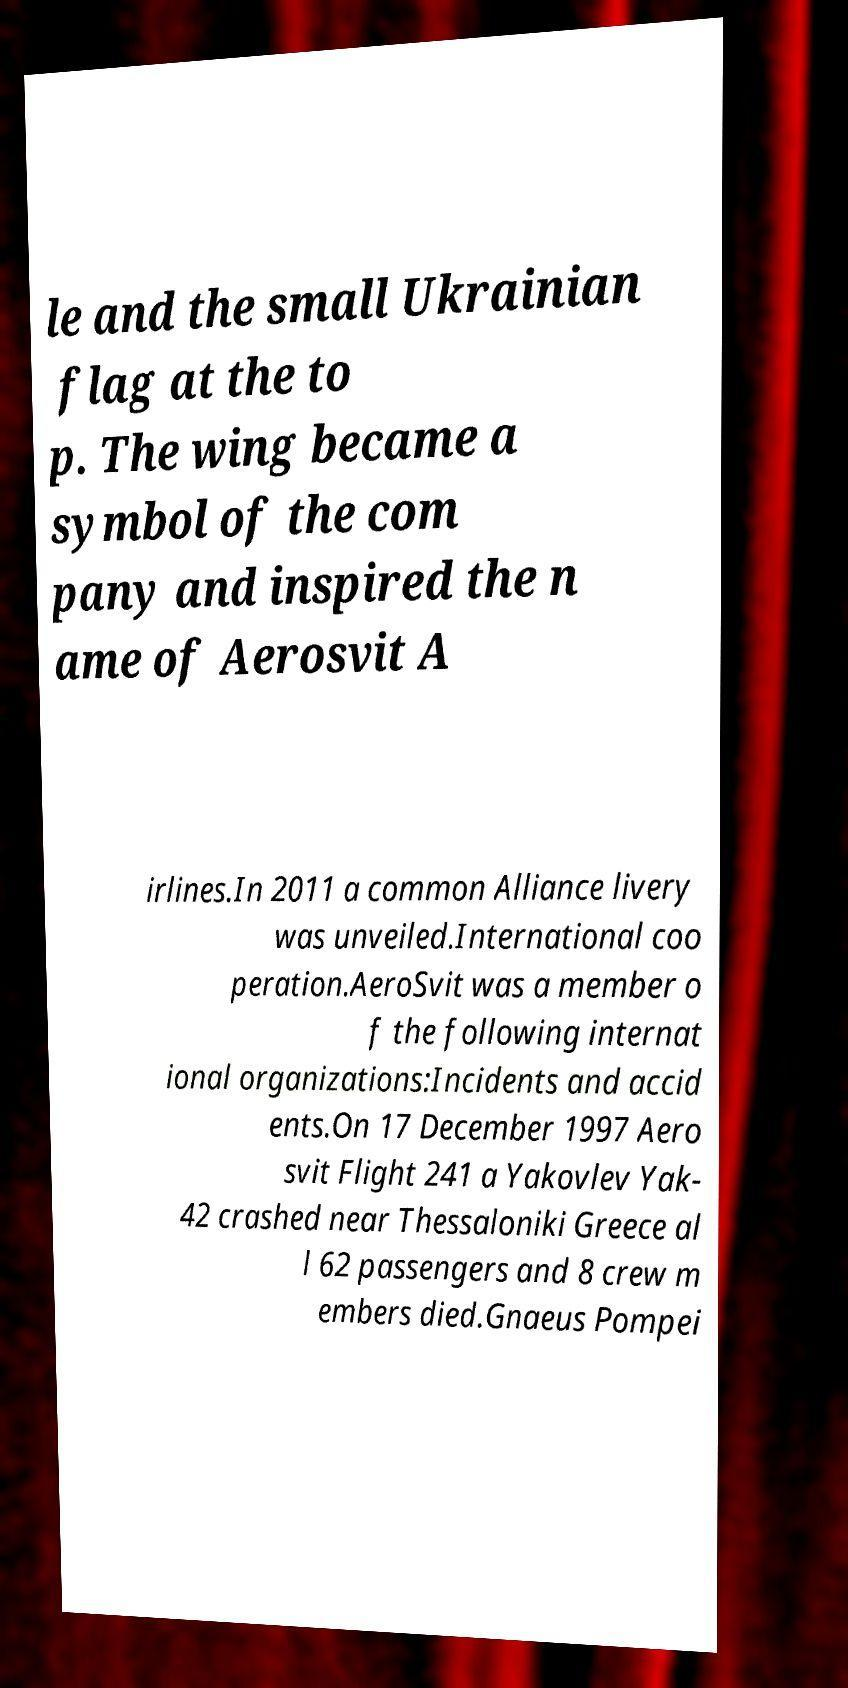Could you extract and type out the text from this image? le and the small Ukrainian flag at the to p. The wing became a symbol of the com pany and inspired the n ame of Aerosvit A irlines.In 2011 a common Alliance livery was unveiled.International coo peration.AeroSvit was a member o f the following internat ional organizations:Incidents and accid ents.On 17 December 1997 Aero svit Flight 241 a Yakovlev Yak- 42 crashed near Thessaloniki Greece al l 62 passengers and 8 crew m embers died.Gnaeus Pompei 